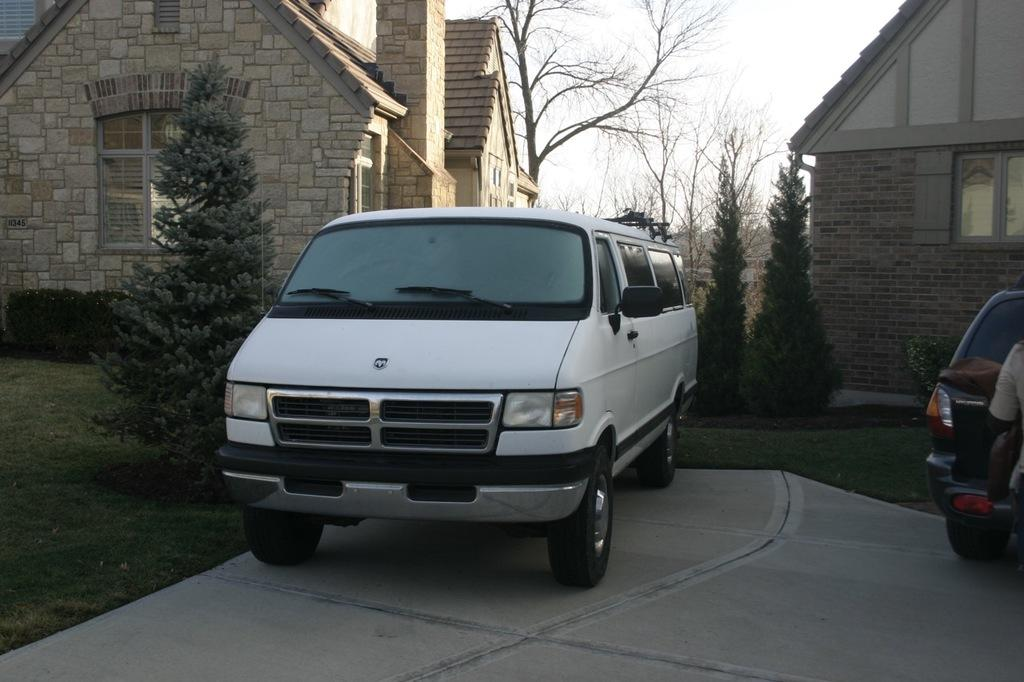What can be seen on the pavement in the image? There are vehicles on the pavement in the image. What type of natural environment is visible on either side of the pavement? There is grassland on either side of the pavement. What can be seen in the background of the image? There are trees, houses, and the sky visible in the background of the image. What type of advertisement can be seen on the house in the image? There is no advertisement present on any house in the image. What type of cub is playing with the vehicles on the pavement? There is no cub present in the image; it features vehicles on a pavement with grassland on either side and a background of trees, houses, and the sky. 